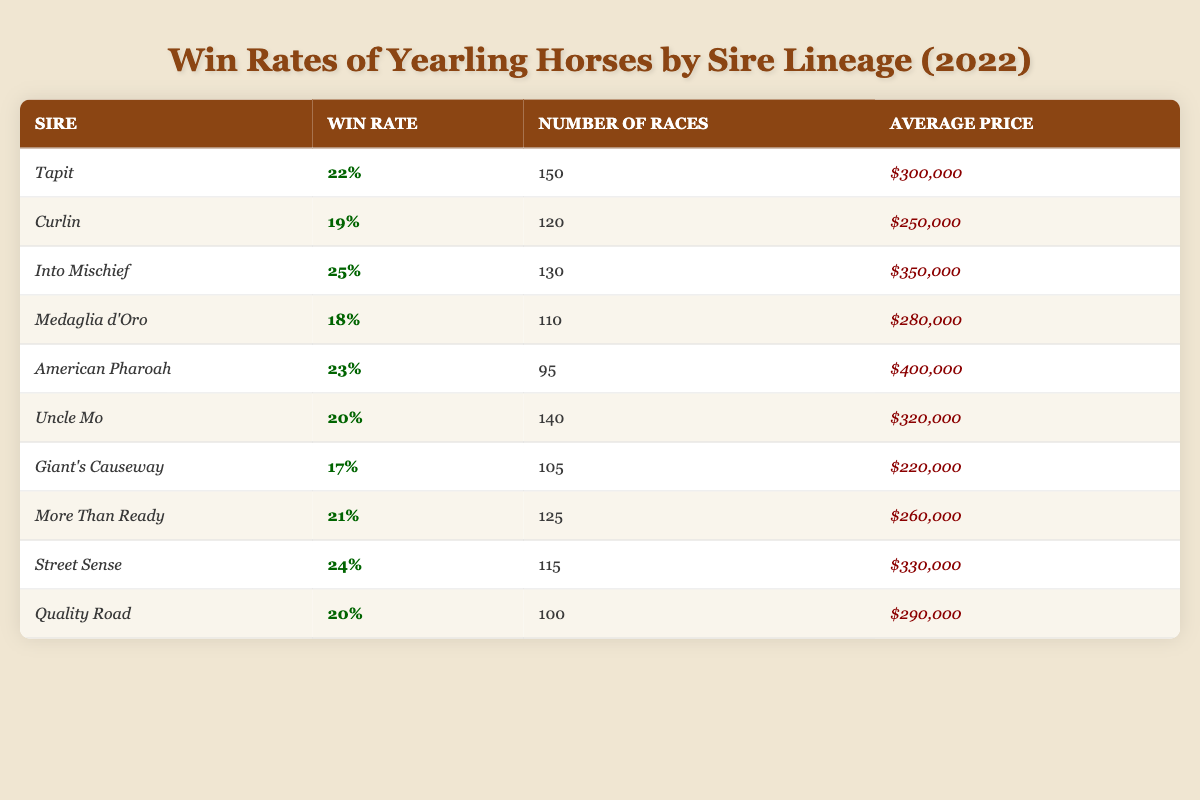What is the win rate for yearling horses sired by Tapit? The win rate for yearling horses sired by Tapit is clearly stated in the table as 22%.
Answer: 22% Which sire has the highest win rate among the listed yearlings? By checking the win rates in the table, Into Mischief has the highest win rate at 25%.
Answer: Into Mischief How many races did yearlings sired by Uncle Mo compete in? The table shows that yearlings sired by Uncle Mo participated in 140 races.
Answer: 140 What is the average price for horses sired by American Pharoah? The average price for horses sired by American Pharoah is listed in the table as $400,000.
Answer: $400,000 Is the win rate for Giant's Causeway higher than that for Curlin? The win rate for Giant's Causeway is 17%, while Curlin has a win rate of 19%. Therefore, Giant's Causeway does not have a higher win rate than Curlin.
Answer: No What is the total number of races competed by all horses sired by Tapit, Curlin, and Into Mischief? The number of races for Tapit is 150, Curlin is 120, and Into Mischief is 130. Adding these gives 150 + 120 + 130 = 400 races in total.
Answer: 400 Determine the average win rate of the horses sired by the top three sires based on win rate. The top three sires based on win rates are Into Mischief (25%), Street Sense (24%), and American Pharoah (23%). Their average is (25 + 24 + 23) / 3 = 24%.
Answer: 24% Which sire had the lowest average price among the listed yearling horses? The average prices show Giant's Causeway with an average price of $220,000, which is lower than all other sires listed.
Answer: Giant's Causeway If a bettor chooses horses sired by More Than Ready, what is their win rate compared to that of Quality Road? More Than Ready has a win rate of 21%, while Quality Road has a win rate of 20%. So, More Than Ready's win rate is higher than Quality Road's.
Answer: Yes, More Than Ready's win rate is higher Which sire had a win rate of 18%? The table shows that Medaglia d'Oro had a win rate of 18%.
Answer: Medaglia d'Oro 